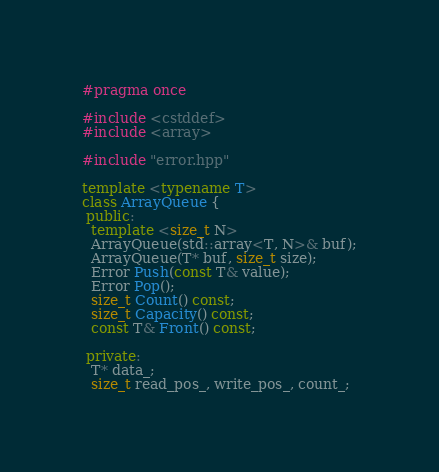Convert code to text. <code><loc_0><loc_0><loc_500><loc_500><_C++_>#pragma once

#include <cstddef>
#include <array>

#include "error.hpp"

template <typename T>
class ArrayQueue {
 public:
  template <size_t N>
  ArrayQueue(std::array<T, N>& buf);
  ArrayQueue(T* buf, size_t size);
  Error Push(const T& value);
  Error Pop();
  size_t Count() const;
  size_t Capacity() const;
  const T& Front() const;

 private:
  T* data_;
  size_t read_pos_, write_pos_, count_;</code> 